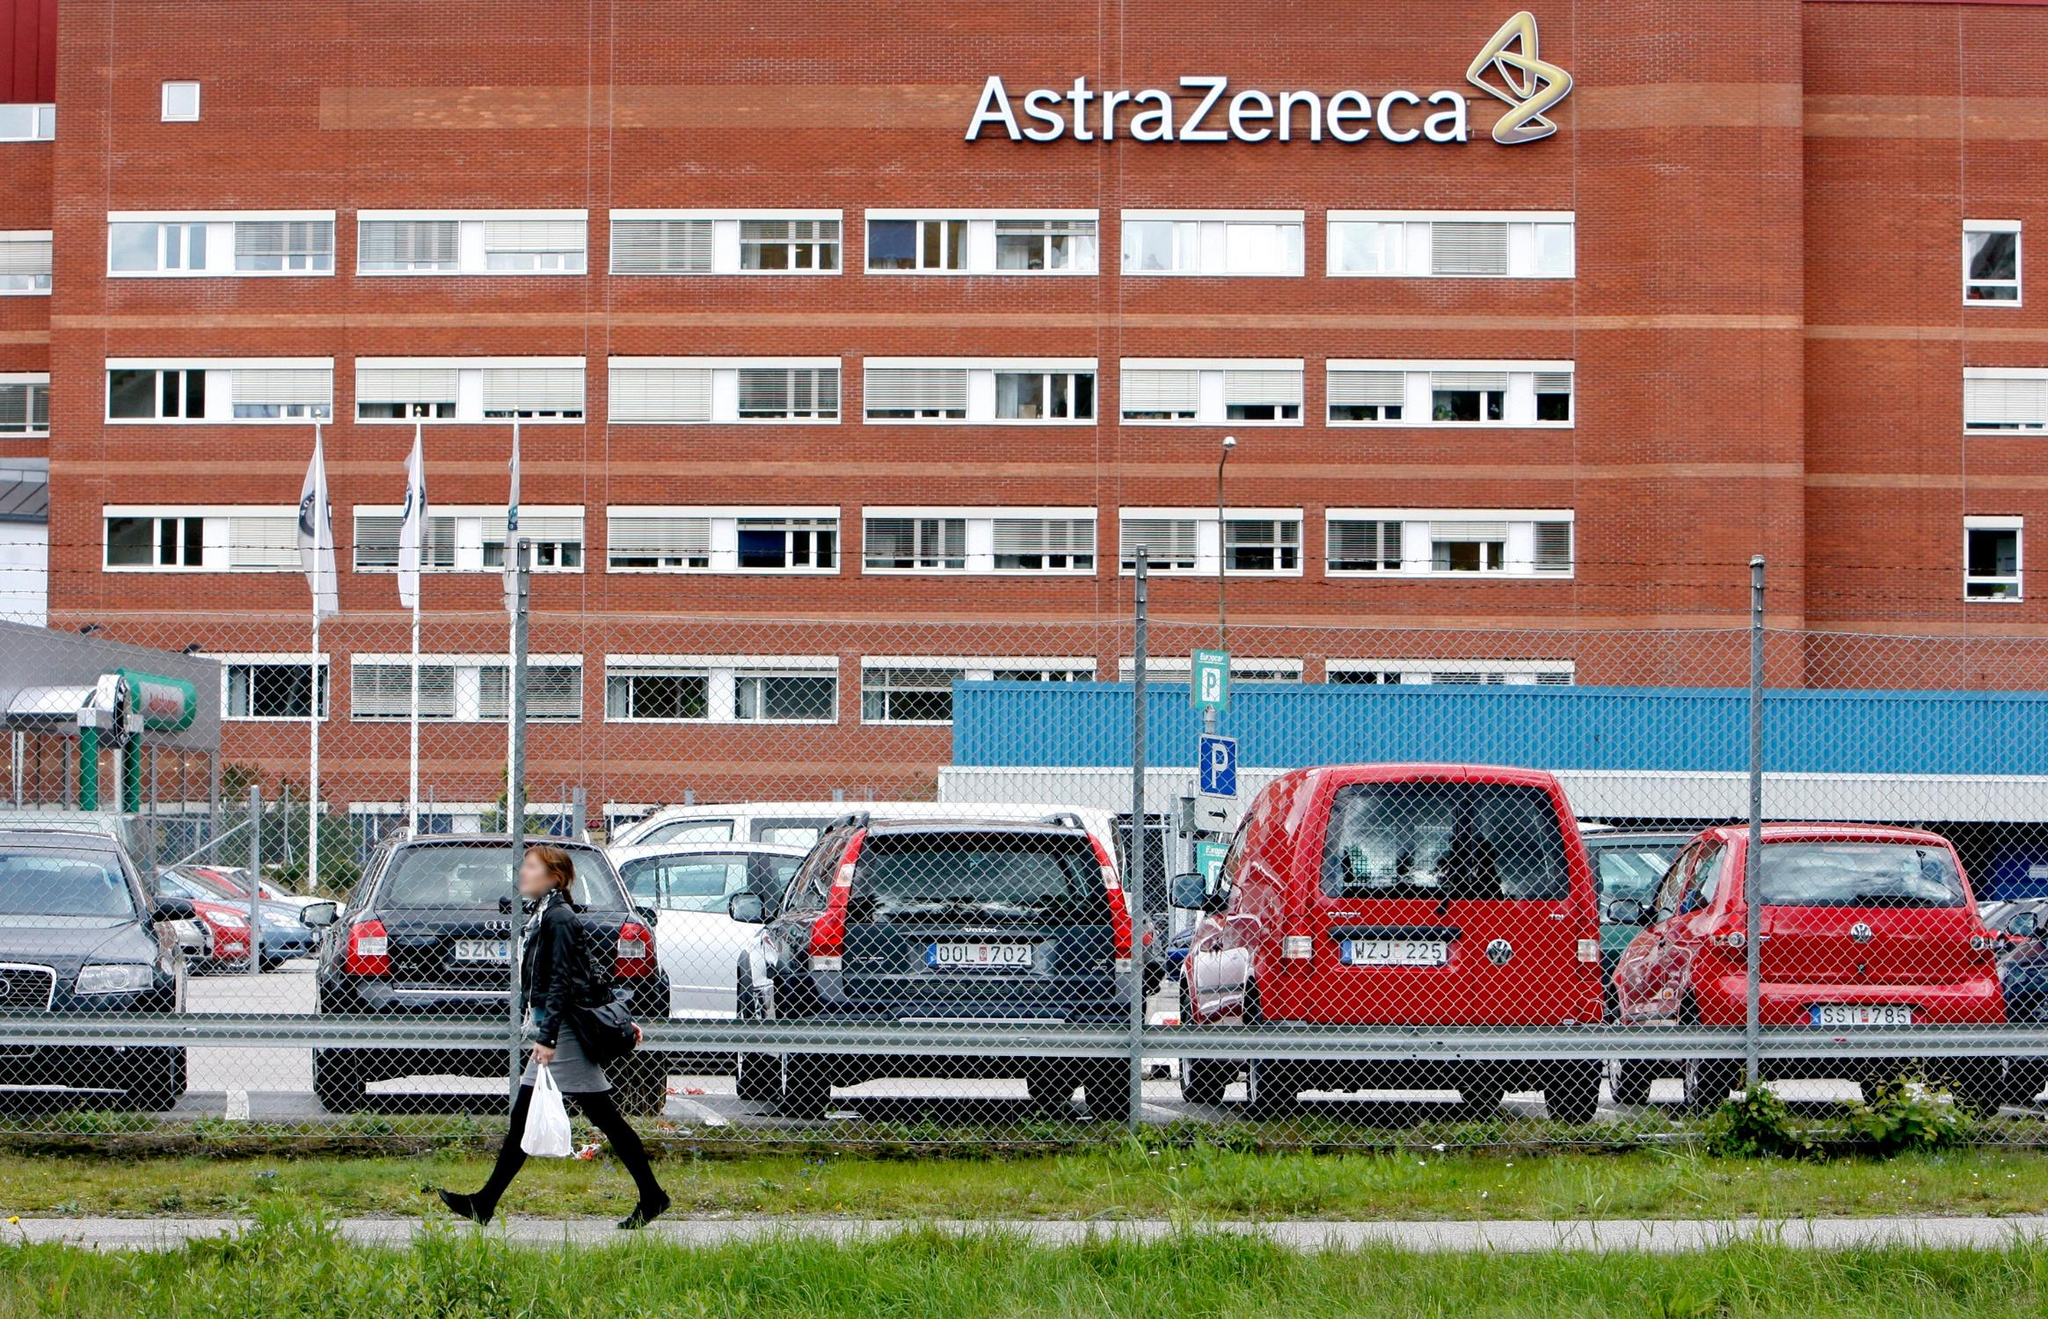What might be one very specific daily scenario that happens at this building? A specific daily scenario at the AstraZeneca building might involve a morning team meeting in one of the conference rooms. At 9:00 AM, researchers and project managers gather around a large table, some joining in virtually. They review the progress of current projects, share data from overnight experiments, and discuss the day’s objectives. The atmosphere is both focused and collaborative, with ideas bouncing around as they strive to solve complex problems. Following the meeting, team members disperse to their labs or offices, ready to dive into the day's work, armed with a clear plan and renewed motivation. 